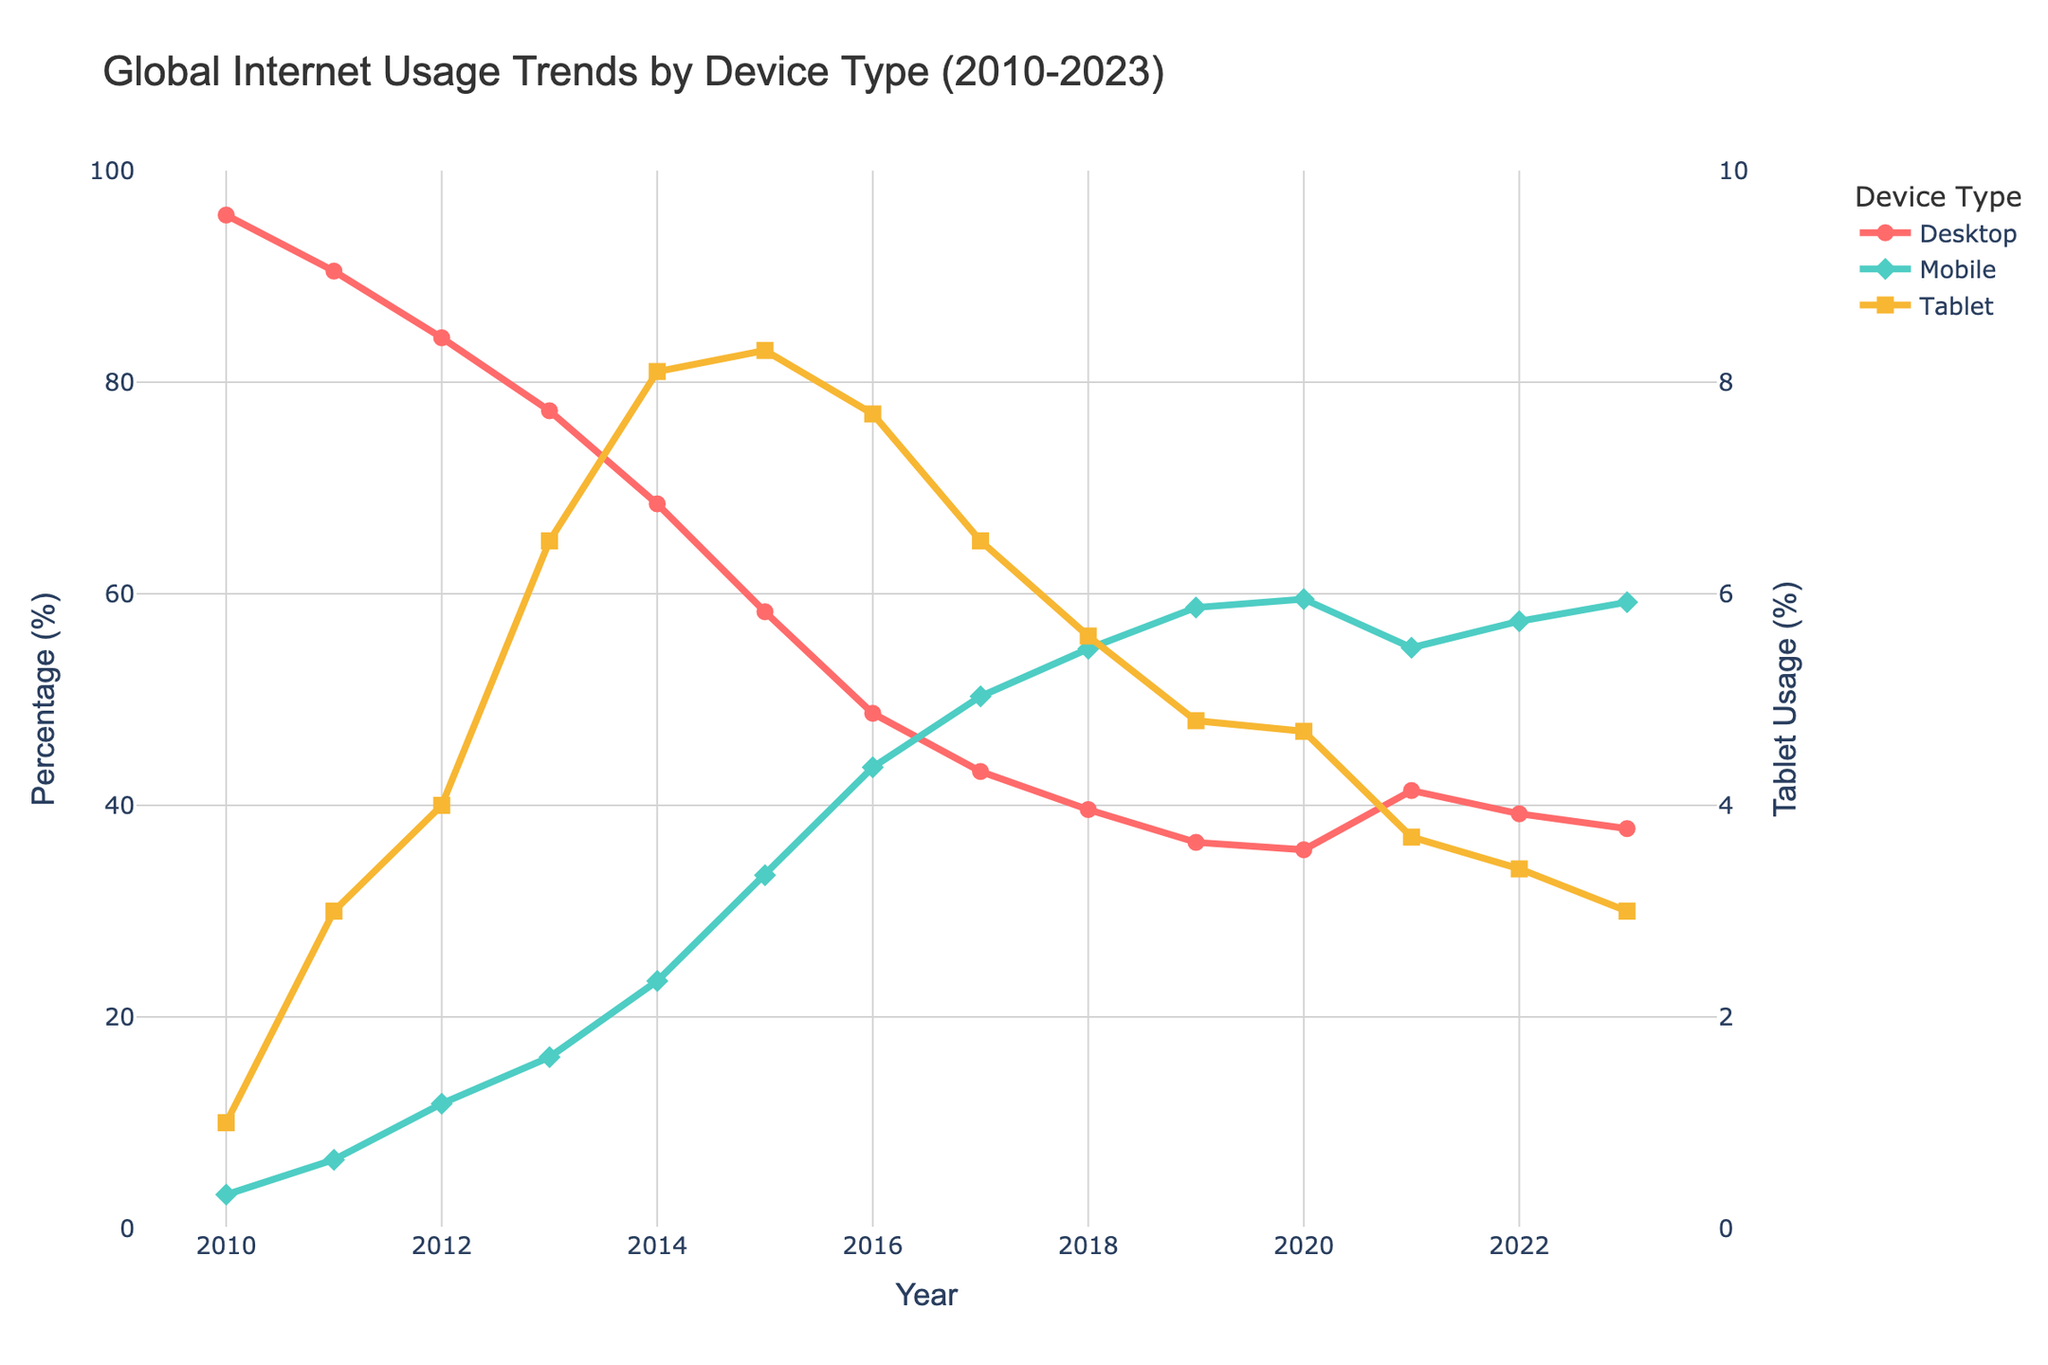What was the percentage of desktop usage in 2010 and how does it compare to 2023? In 2010, desktop usage was 95.8%. In 2023, it dropped to 37.8%. To compare, we subtract the percentage in 2023 from the percentage in 2010: 95.8% - 37.8% = 58%.
Answer: Desktop usage decreased by 58% Which year had the highest mobile usage and what was the percentage? By inspecting the "Mobile" line in the figure, we see the peak is in 2023. The percentage is found at the end of this line: 59.2%.
Answer: 2023 with 59.2% How does tablet usage in 2013 compare to 2020? In 2013, tablet usage was 6.5%. In 2020, it was 4.7%. The change can be calculated as 6.5% - 4.7% = 1.8%.
Answer: Tablet usage decreased by 1.8% What is the average mobile usage across the entire period (2010-2023)? Sum the mobile usage percentages for all years and divide by the number of years. (3.2+6.5+11.8+16.2+23.4+33.4+43.6+50.3+54.8+58.7+59.5+54.9+57.4+59.2) / 14 = 38.8%
Answer: 38.8% In which year did desktop and mobile usage intersect? Locate the point where the desktop and mobile lines intersect on the plot. This occurs around 2016, where both were approximately equal at around 48.7% for desktops and 43.6% for mobiles.
Answer: 2016 What were the lowest usage percentages for desktop, mobile, and tablet, respectively? Inspect the lowest points for each line in the figure. Desktop: 35.8% in 2020, Mobile: 3.2% in 2010, Tablet: 1.0% in 2010.
Answer: Desktop: 35.8%, Mobile: 3.2%, Tablet: 1.0% How much did tablet usage decrease from its peak to 2023? Tablet usage peaked in 2014 at 8.3%. By 2023, it dropped to 3.0%. The difference is 8.3% - 3.0% = 5.3%.
Answer: Decreased by 5.3% What is the general trend for mobile usage from 2010 to 2023? The line representing mobile usage consistently ascends, indicating a general upward trend. The specific trend can be described as an increase from 3.2% in 2010 to 59.2% in 2023.
Answer: Upward trend Which device type showed the most significant change in usage percentage over the given period? Desktop usage decreased significantly, from 95.8% in 2010 to 37.8% in 2023, a change of 58%. In contrast, mobile usage increased substantially, from 3.2% in 2010 to 59.2% in 2023, a change of 56%. Tablets did not show as drastic a change.
Answer: Desktop usage with a decrease of 58% 